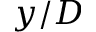<formula> <loc_0><loc_0><loc_500><loc_500>y / D</formula> 